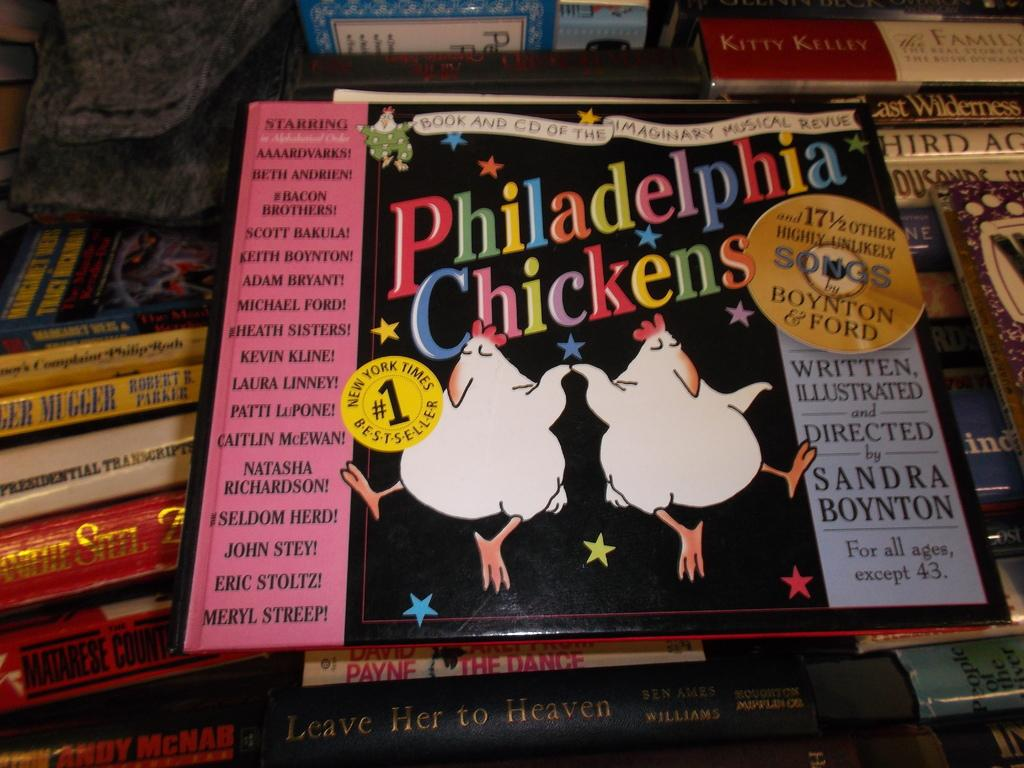<image>
Present a compact description of the photo's key features. Sandra Boynton's Philidelphia Chickens best selling collection of soungs. 